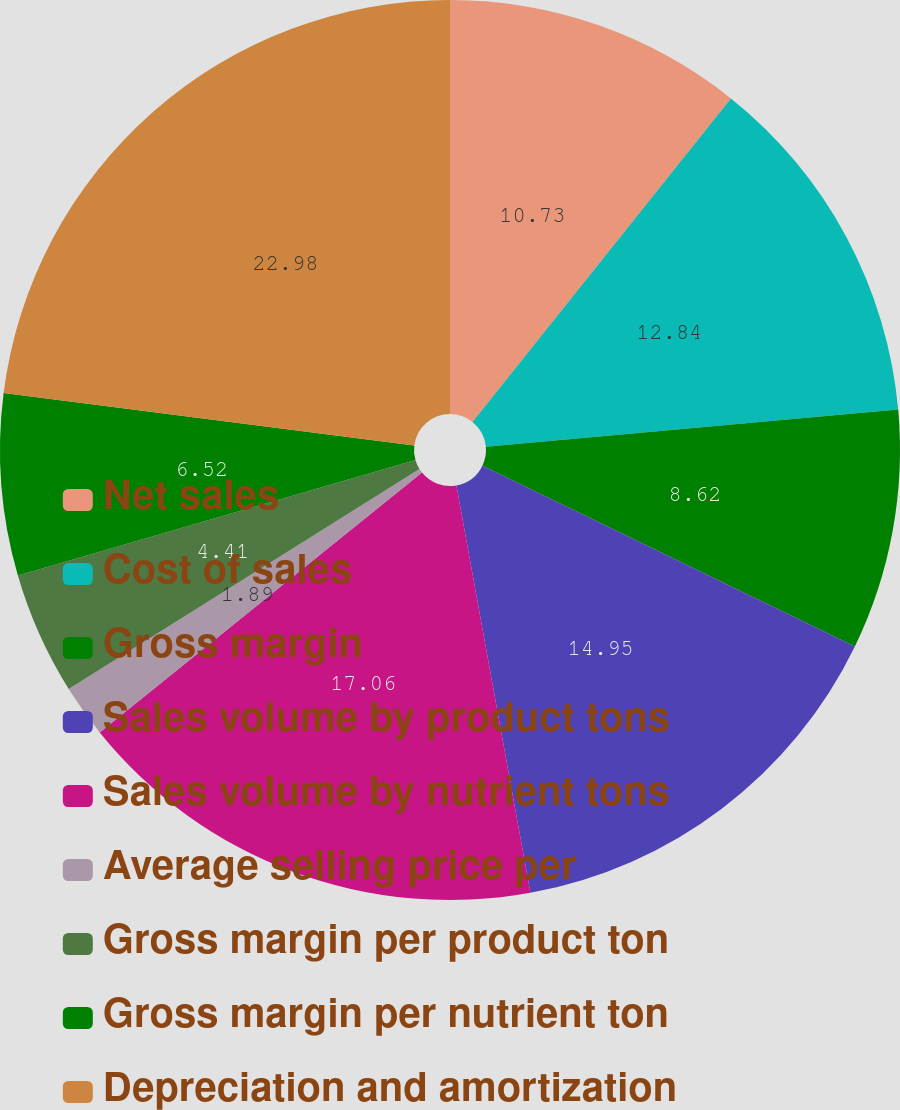<chart> <loc_0><loc_0><loc_500><loc_500><pie_chart><fcel>Net sales<fcel>Cost of sales<fcel>Gross margin<fcel>Sales volume by product tons<fcel>Sales volume by nutrient tons<fcel>Average selling price per<fcel>Gross margin per product ton<fcel>Gross margin per nutrient ton<fcel>Depreciation and amortization<nl><fcel>10.73%<fcel>12.84%<fcel>8.62%<fcel>14.95%<fcel>17.06%<fcel>1.89%<fcel>4.41%<fcel>6.52%<fcel>22.98%<nl></chart> 